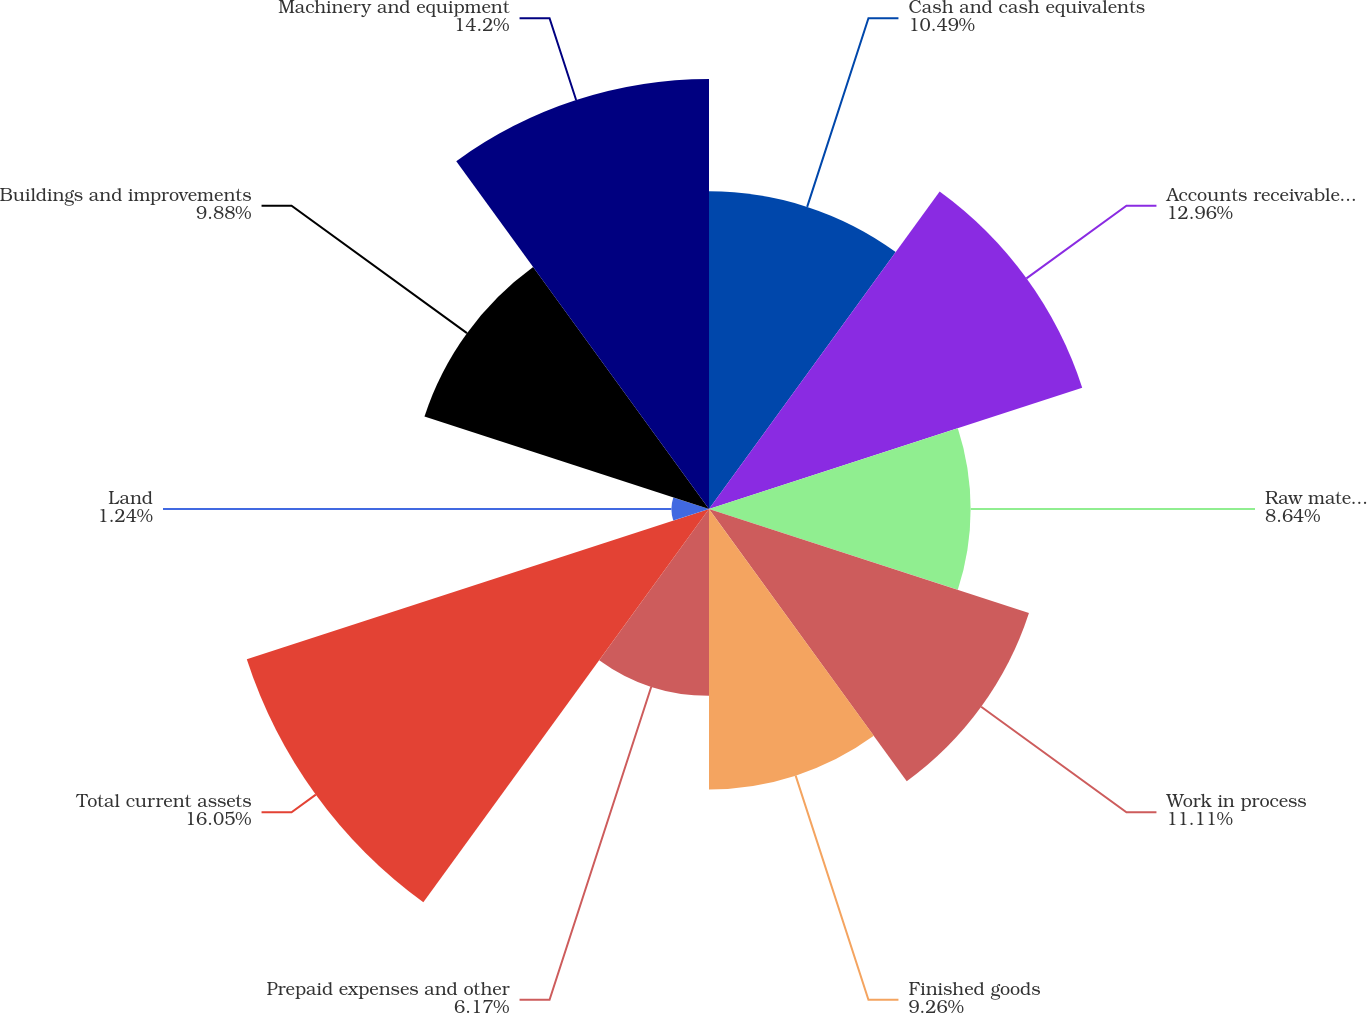Convert chart. <chart><loc_0><loc_0><loc_500><loc_500><pie_chart><fcel>Cash and cash equivalents<fcel>Accounts receivable less<fcel>Raw materials and supplies<fcel>Work in process<fcel>Finished goods<fcel>Prepaid expenses and other<fcel>Total current assets<fcel>Land<fcel>Buildings and improvements<fcel>Machinery and equipment<nl><fcel>10.49%<fcel>12.96%<fcel>8.64%<fcel>11.11%<fcel>9.26%<fcel>6.17%<fcel>16.05%<fcel>1.24%<fcel>9.88%<fcel>14.2%<nl></chart> 